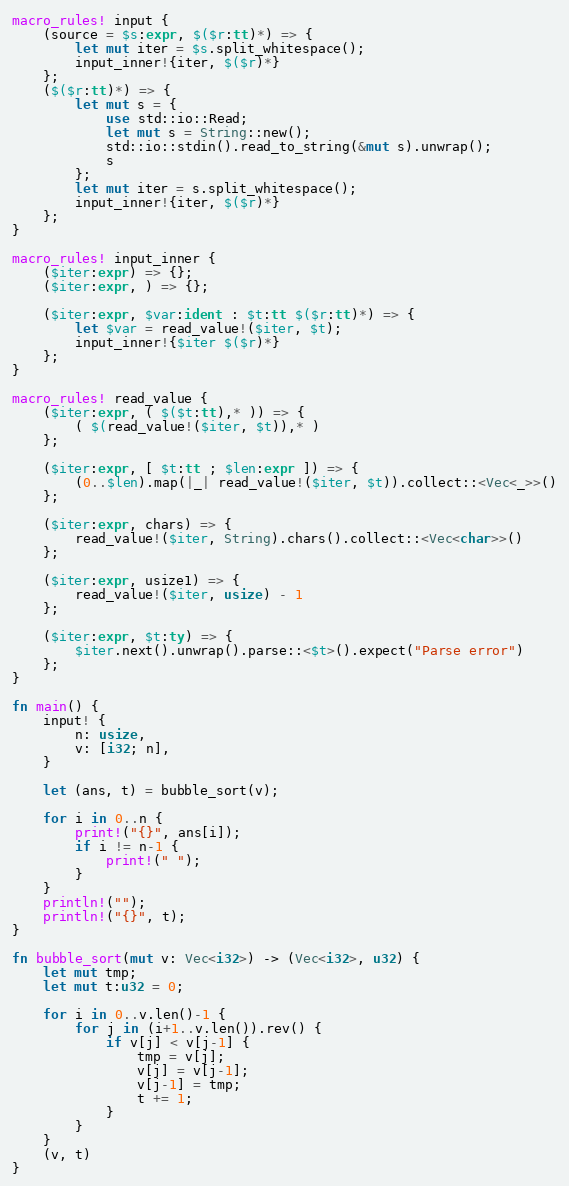Convert code to text. <code><loc_0><loc_0><loc_500><loc_500><_Rust_>macro_rules! input {
    (source = $s:expr, $($r:tt)*) => {
        let mut iter = $s.split_whitespace();
        input_inner!{iter, $($r)*}
    };
    ($($r:tt)*) => {
        let mut s = {
            use std::io::Read;
            let mut s = String::new();
            std::io::stdin().read_to_string(&mut s).unwrap();
            s
        };
        let mut iter = s.split_whitespace();
        input_inner!{iter, $($r)*}
    };
}

macro_rules! input_inner {
    ($iter:expr) => {};
    ($iter:expr, ) => {};

    ($iter:expr, $var:ident : $t:tt $($r:tt)*) => {
        let $var = read_value!($iter, $t);
        input_inner!{$iter $($r)*}
    };
}

macro_rules! read_value {
    ($iter:expr, ( $($t:tt),* )) => {
        ( $(read_value!($iter, $t)),* )
    };

    ($iter:expr, [ $t:tt ; $len:expr ]) => {
        (0..$len).map(|_| read_value!($iter, $t)).collect::<Vec<_>>()
    };

    ($iter:expr, chars) => {
        read_value!($iter, String).chars().collect::<Vec<char>>()
    };

    ($iter:expr, usize1) => {
        read_value!($iter, usize) - 1
    };

    ($iter:expr, $t:ty) => {
        $iter.next().unwrap().parse::<$t>().expect("Parse error")
    };
}

fn main() {
    input! {
        n: usize,
        v: [i32; n],
    }

    let (ans, t) = bubble_sort(v);

    for i in 0..n {
        print!("{}", ans[i]);
        if i != n-1 {
            print!(" ");
        }
    }
    println!("");
    println!("{}", t);
}

fn bubble_sort(mut v: Vec<i32>) -> (Vec<i32>, u32) {
    let mut tmp;
    let mut t:u32 = 0;

    for i in 0..v.len()-1 {
        for j in (i+1..v.len()).rev() {
            if v[j] < v[j-1] {
                tmp = v[j];
                v[j] = v[j-1];
                v[j-1] = tmp;
                t += 1;
            }
        }
    }
    (v, t)
}

</code> 